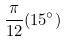Convert formula to latex. <formula><loc_0><loc_0><loc_500><loc_500>\frac { \pi } { 1 2 } ( 1 5 ^ { \circ } )</formula> 